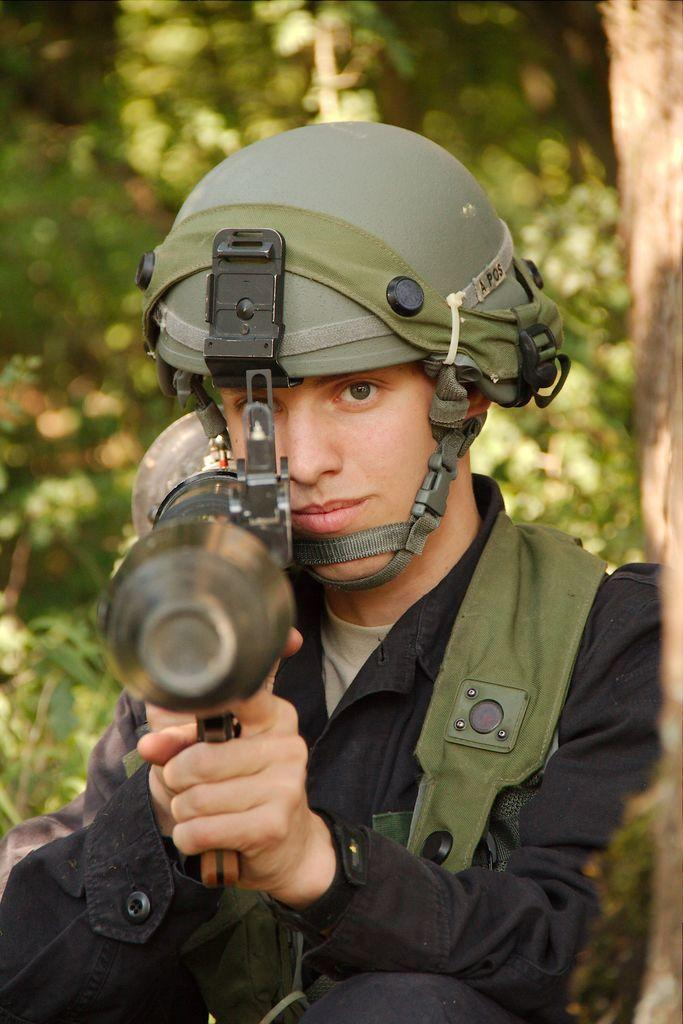Who is present in the image? There is a man in the image. What is the man wearing on his head? The man is wearing a helmet. What is the man holding in his hands? The man is holding a gun. Where is the man positioned in relation to the tree trunk? The man is beside a tree trunk. What can be seen in the background of the image? There are many trees visible in the background. What type of club does the man use to hit the soda in the image? There is no club or soda present in the image; the man is holding a gun and is beside a tree trunk. 